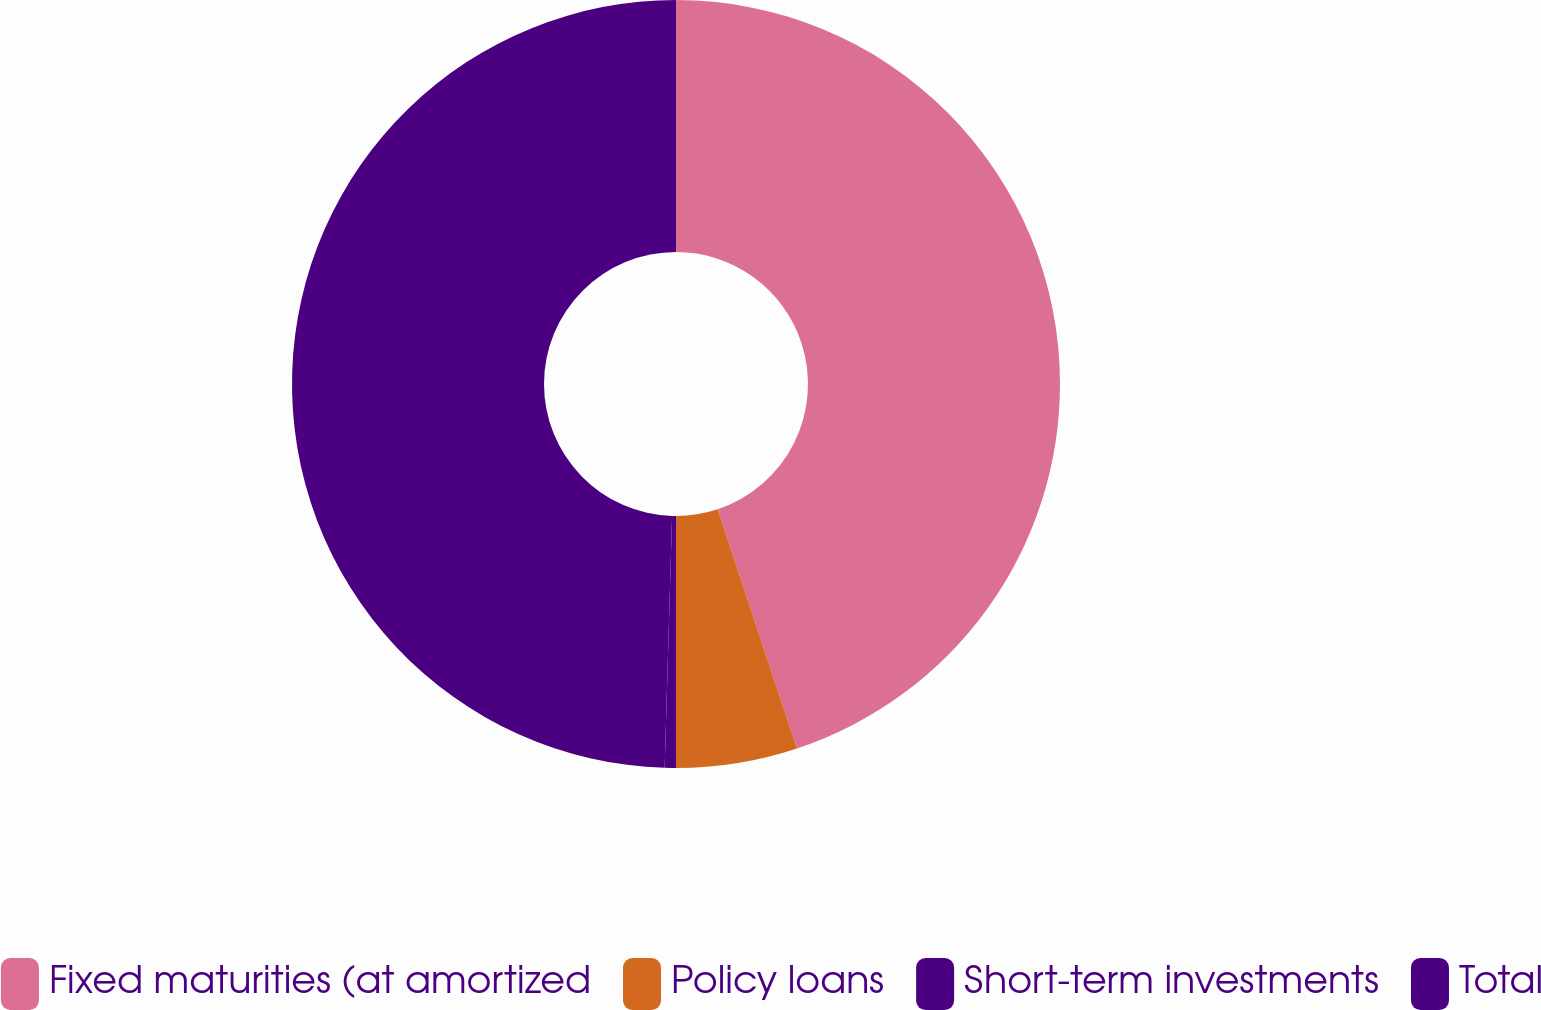Convert chart to OTSL. <chart><loc_0><loc_0><loc_500><loc_500><pie_chart><fcel>Fixed maturities (at amortized<fcel>Policy loans<fcel>Short-term investments<fcel>Total<nl><fcel>44.9%<fcel>5.1%<fcel>0.47%<fcel>49.53%<nl></chart> 